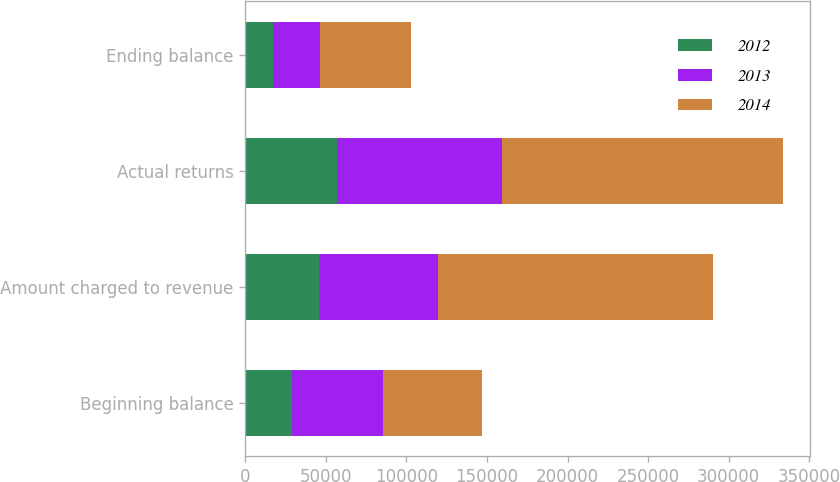Convert chart to OTSL. <chart><loc_0><loc_0><loc_500><loc_500><stacked_bar_chart><ecel><fcel>Beginning balance<fcel>Amount charged to revenue<fcel>Actual returns<fcel>Ending balance<nl><fcel>2012<fcel>28664<fcel>45550<fcel>56812<fcel>17402<nl><fcel>2013<fcel>57058<fcel>74031<fcel>102425<fcel>28664<nl><fcel>2014<fcel>60887<fcel>170839<fcel>174668<fcel>57058<nl></chart> 